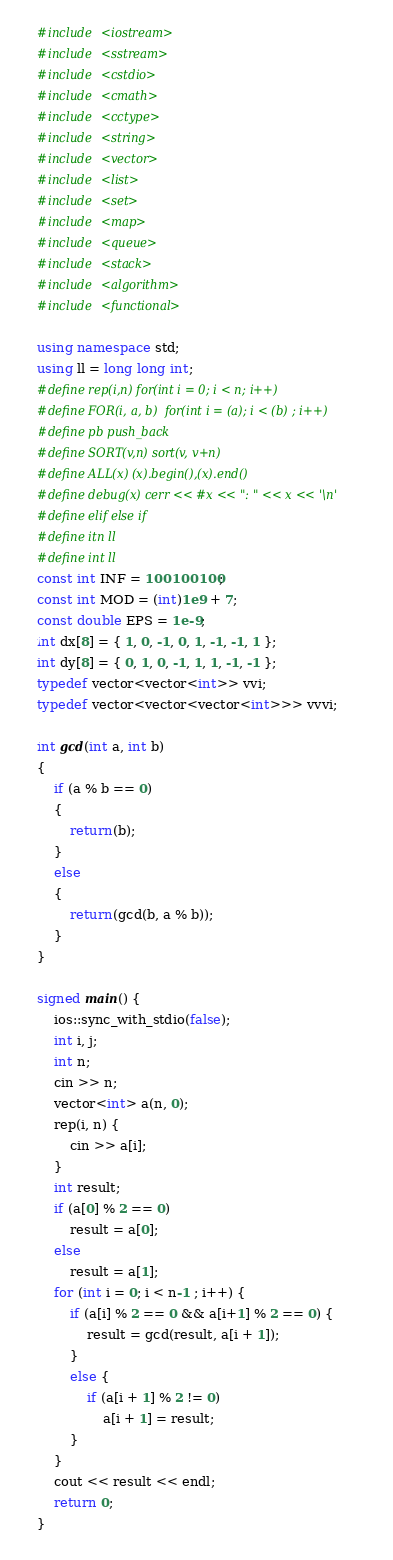<code> <loc_0><loc_0><loc_500><loc_500><_C++_>#include <iostream>
#include <sstream>
#include <cstdio>
#include <cmath>
#include <cctype>
#include <string>
#include <vector>
#include <list>
#include <set>
#include <map>
#include <queue>
#include <stack>
#include <algorithm>
#include <functional>

using namespace std;
using ll = long long int;
#define rep(i,n) for(int i = 0; i < n; i++)
#define FOR(i, a, b)  for(int i = (a); i < (b) ; i++)
#define pb push_back
#define SORT(v,n) sort(v, v+n)
#define ALL(x) (x).begin(),(x).end()
#define debug(x) cerr << #x << ": " << x << '\n'
#define elif else if
#define itn ll
#define int ll
const int INF = 100100100;
const int MOD = (int)1e9 + 7;
const double EPS = 1e-9;
int dx[8] = { 1, 0, -1, 0, 1, -1, -1, 1 };
int dy[8] = { 0, 1, 0, -1, 1, 1, -1, -1 };
typedef vector<vector<int>> vvi;
typedef vector<vector<vector<int>>> vvvi;

int gcd(int a, int b)
{
	if (a % b == 0)
	{
		return(b);
	}
	else
	{
		return(gcd(b, a % b));
	}
}

signed main() {
	ios::sync_with_stdio(false);
	int i, j;
	int n;
	cin >> n;
	vector<int> a(n, 0);
	rep(i, n) {
		cin >> a[i];
	}
	int result;
	if (a[0] % 2 == 0)
		result = a[0];
	else
		result = a[1];
	for (int i = 0; i < n-1 ; i++) {
		if (a[i] % 2 == 0 && a[i+1] % 2 == 0) {
			result = gcd(result, a[i + 1]);
		}
		else {
			if (a[i + 1] % 2 != 0)
				a[i + 1] = result;
		}
	}
	cout << result << endl;
	return 0;
}</code> 